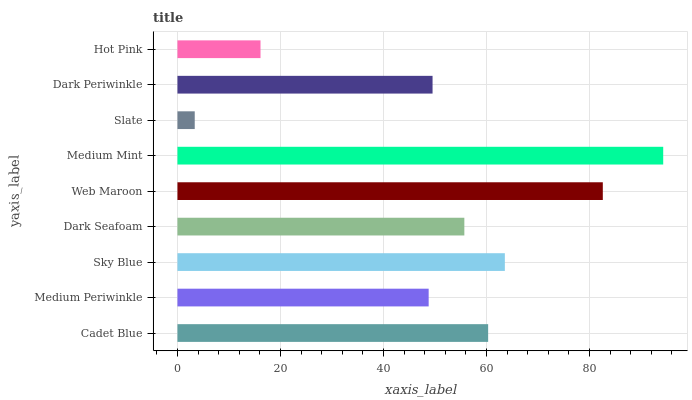Is Slate the minimum?
Answer yes or no. Yes. Is Medium Mint the maximum?
Answer yes or no. Yes. Is Medium Periwinkle the minimum?
Answer yes or no. No. Is Medium Periwinkle the maximum?
Answer yes or no. No. Is Cadet Blue greater than Medium Periwinkle?
Answer yes or no. Yes. Is Medium Periwinkle less than Cadet Blue?
Answer yes or no. Yes. Is Medium Periwinkle greater than Cadet Blue?
Answer yes or no. No. Is Cadet Blue less than Medium Periwinkle?
Answer yes or no. No. Is Dark Seafoam the high median?
Answer yes or no. Yes. Is Dark Seafoam the low median?
Answer yes or no. Yes. Is Medium Mint the high median?
Answer yes or no. No. Is Cadet Blue the low median?
Answer yes or no. No. 